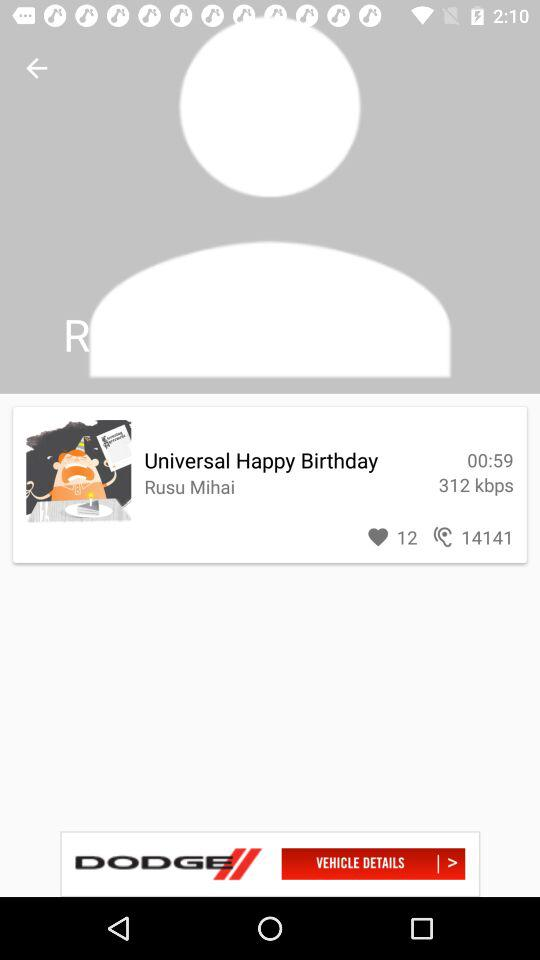How many kbps are shown there? There are 312 kbps shown. 